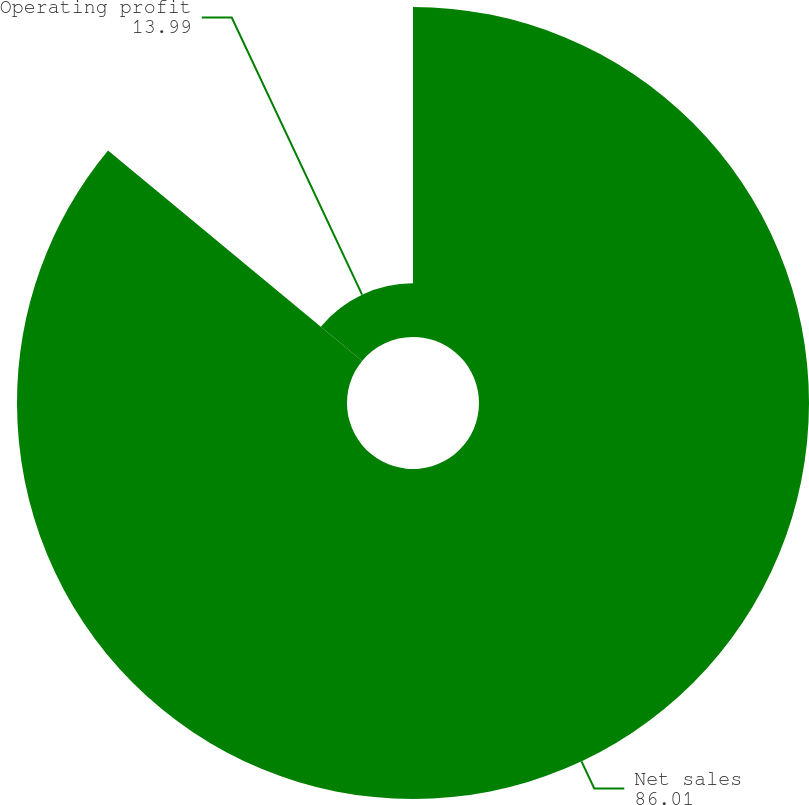Convert chart to OTSL. <chart><loc_0><loc_0><loc_500><loc_500><pie_chart><fcel>Net sales<fcel>Operating profit<nl><fcel>86.01%<fcel>13.99%<nl></chart> 